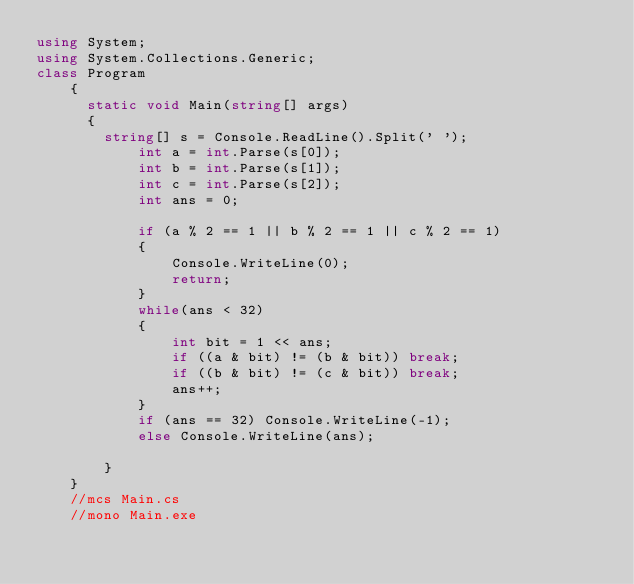Convert code to text. <code><loc_0><loc_0><loc_500><loc_500><_C#_>using System;
using System.Collections.Generic;
class Program
    {
    	static void Main(string[] args)
    	{
    		string[] s = Console.ReadLine().Split(' ');
            int a = int.Parse(s[0]);
            int b = int.Parse(s[1]);
            int c = int.Parse(s[2]);
            int ans = 0;

            if (a % 2 == 1 || b % 2 == 1 || c % 2 == 1)
            {
                Console.WriteLine(0);
                return;
            }
            while(ans < 32)
            {
                int bit = 1 << ans;
                if ((a & bit) != (b & bit)) break;
                if ((b & bit) != (c & bit)) break;
                ans++;
            }
            if (ans == 32) Console.WriteLine(-1);
            else Console.WriteLine(ans);
            
        }
    }
    //mcs Main.cs
    //mono Main.exe</code> 